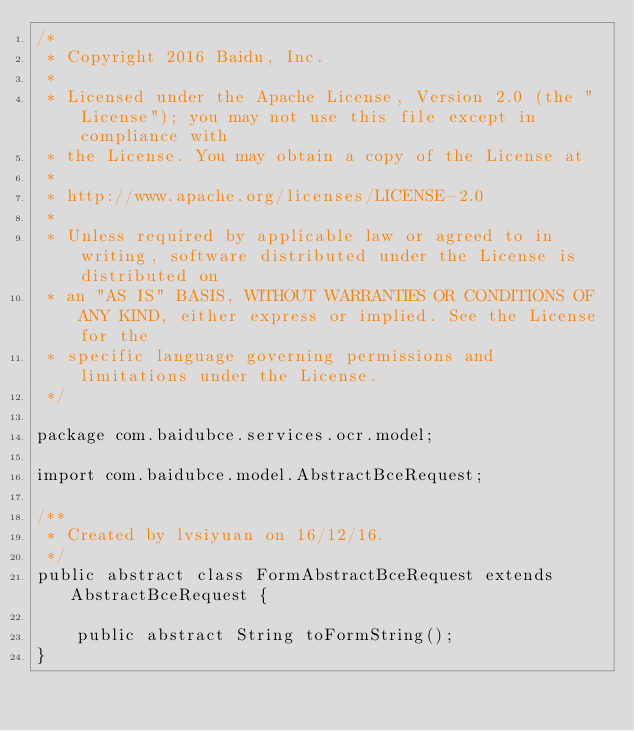Convert code to text. <code><loc_0><loc_0><loc_500><loc_500><_Java_>/*
 * Copyright 2016 Baidu, Inc.
 *
 * Licensed under the Apache License, Version 2.0 (the "License"); you may not use this file except in compliance with
 * the License. You may obtain a copy of the License at
 *
 * http://www.apache.org/licenses/LICENSE-2.0
 *
 * Unless required by applicable law or agreed to in writing, software distributed under the License is distributed on
 * an "AS IS" BASIS, WITHOUT WARRANTIES OR CONDITIONS OF ANY KIND, either express or implied. See the License for the
 * specific language governing permissions and limitations under the License.
 */

package com.baidubce.services.ocr.model;

import com.baidubce.model.AbstractBceRequest;

/**
 * Created by lvsiyuan on 16/12/16.
 */
public abstract class FormAbstractBceRequest extends AbstractBceRequest {

    public abstract String toFormString();
}
</code> 